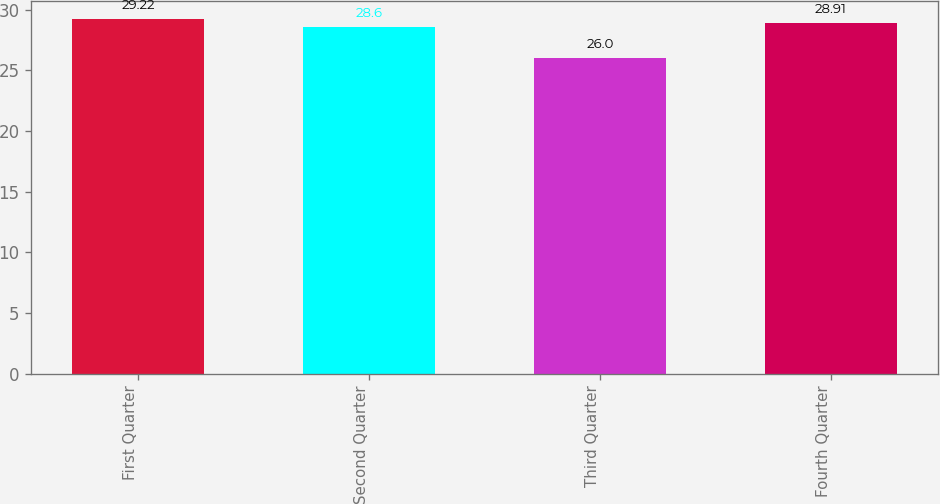Convert chart to OTSL. <chart><loc_0><loc_0><loc_500><loc_500><bar_chart><fcel>First Quarter<fcel>Second Quarter<fcel>Third Quarter<fcel>Fourth Quarter<nl><fcel>29.22<fcel>28.6<fcel>26<fcel>28.91<nl></chart> 